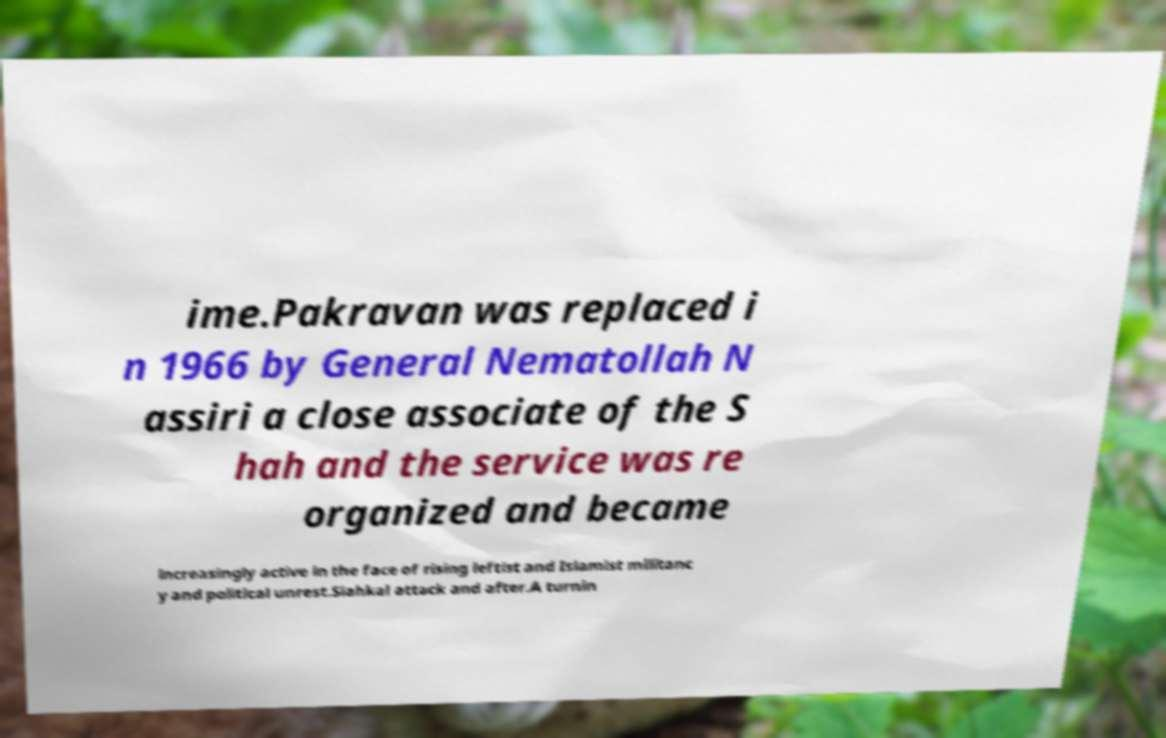Can you accurately transcribe the text from the provided image for me? ime.Pakravan was replaced i n 1966 by General Nematollah N assiri a close associate of the S hah and the service was re organized and became increasingly active in the face of rising leftist and Islamist militanc y and political unrest.Siahkal attack and after.A turnin 